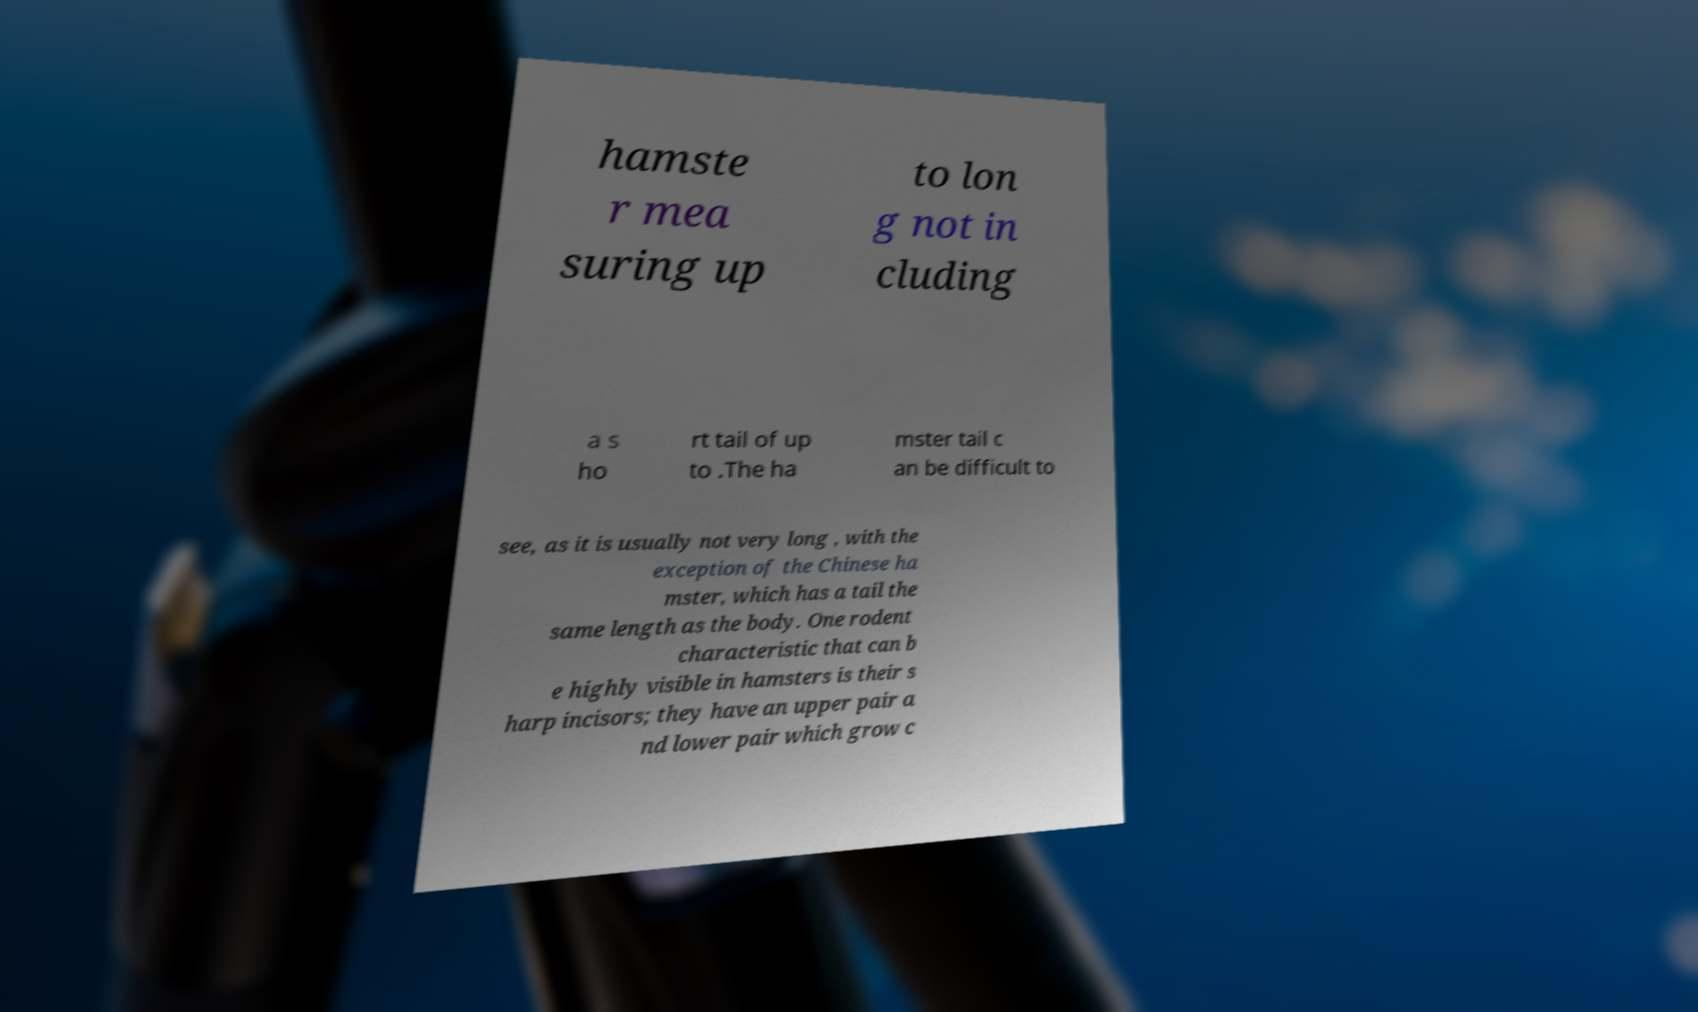There's text embedded in this image that I need extracted. Can you transcribe it verbatim? hamste r mea suring up to lon g not in cluding a s ho rt tail of up to .The ha mster tail c an be difficult to see, as it is usually not very long , with the exception of the Chinese ha mster, which has a tail the same length as the body. One rodent characteristic that can b e highly visible in hamsters is their s harp incisors; they have an upper pair a nd lower pair which grow c 